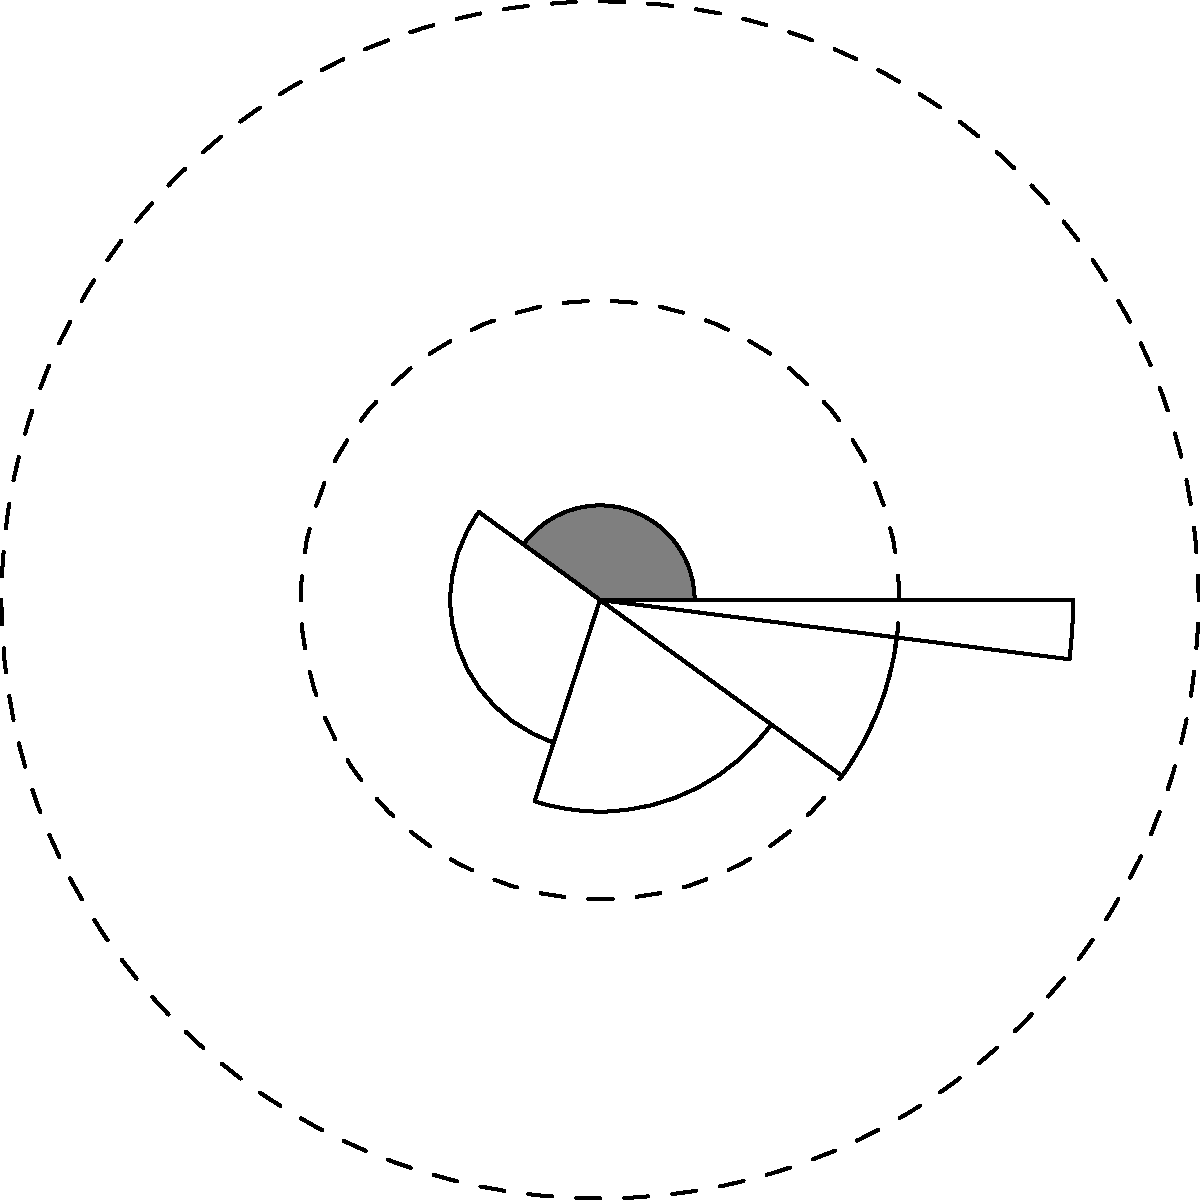In the polar area diagram above, which represents income distribution across different population segments, what does the area of each sector primarily represent? To understand what the area of each sector represents in this polar area diagram, let's break down the components:

1. Angle of each sector: The angle is proportional to the population percentage in each income group. The full circle (360°) represents 100% of the population.

2. Radius of each sector: The radius is proportional to the square root of the income for that group. This is because the area of a circle is proportional to the square of its radius (A = πr²).

3. Area of each sector: The area is a product of both the angle (population) and the square of the radius (income).

Therefore, the area of each sector is proportional to:
$$ \text{Area} \propto \text{Population} \times \text{Income} $$

This means that the area of each sector represents the total income for that population segment. It combines both the size of the population in that income group and their income level.

In economics, this representation is particularly useful for visualizing income inequality. Larger areas indicate segments of the population that hold a larger share of the total income, while smaller areas represent segments with a smaller share of the total income.
Answer: Total income for each population segment 